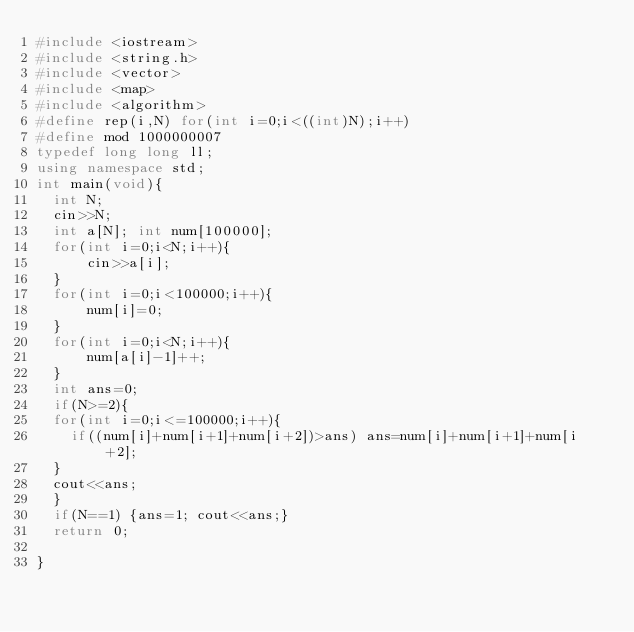Convert code to text. <code><loc_0><loc_0><loc_500><loc_500><_C++_>#include <iostream>
#include <string.h>
#include <vector>
#include <map>
#include <algorithm>
#define rep(i,N) for(int i=0;i<((int)N);i++)
#define mod 1000000007
typedef long long ll;
using namespace std;
int main(void){
  int N;
  cin>>N;
  int a[N]; int num[100000];
  for(int i=0;i<N;i++){
      cin>>a[i];
  }
  for(int i=0;i<100000;i++){
      num[i]=0;
  }
  for(int i=0;i<N;i++){
      num[a[i]-1]++;
  }
  int ans=0;
  if(N>=2){
  for(int i=0;i<=100000;i++){
    if((num[i]+num[i+1]+num[i+2])>ans) ans=num[i]+num[i+1]+num[i+2];
  }
  cout<<ans;
  }
  if(N==1) {ans=1; cout<<ans;}
  return 0;
  
}
</code> 